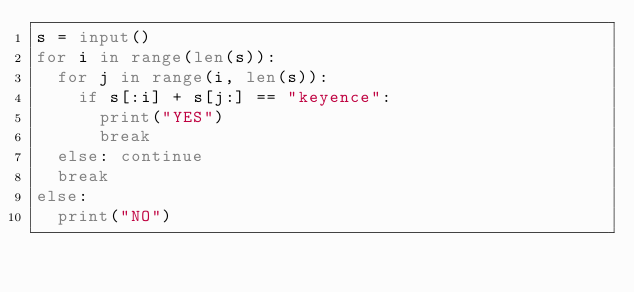Convert code to text. <code><loc_0><loc_0><loc_500><loc_500><_Python_>s = input()
for i in range(len(s)):
	for j in range(i, len(s)):
		if s[:i] + s[j:] == "keyence":
			print("YES")
			break
	else: continue
	break
else:
	print("NO")</code> 